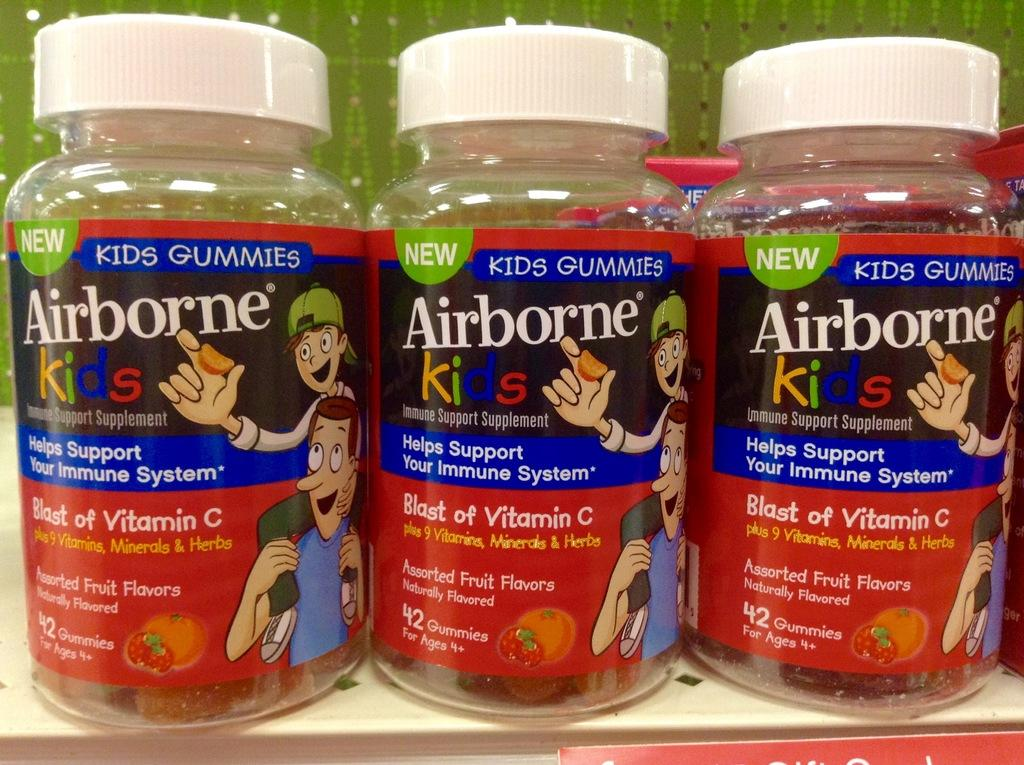How many bottles are visible in the image? There are three bottles in the image. What color are the caps on the bottles? The caps on the bottles have a white color. What is written on the stickers of the bottles? The stickers on the bottles have "AIRBORNE KIDS" printed on them. What type of chin is visible on the bottles in the image? There is no chin visible on the bottles in the image. 